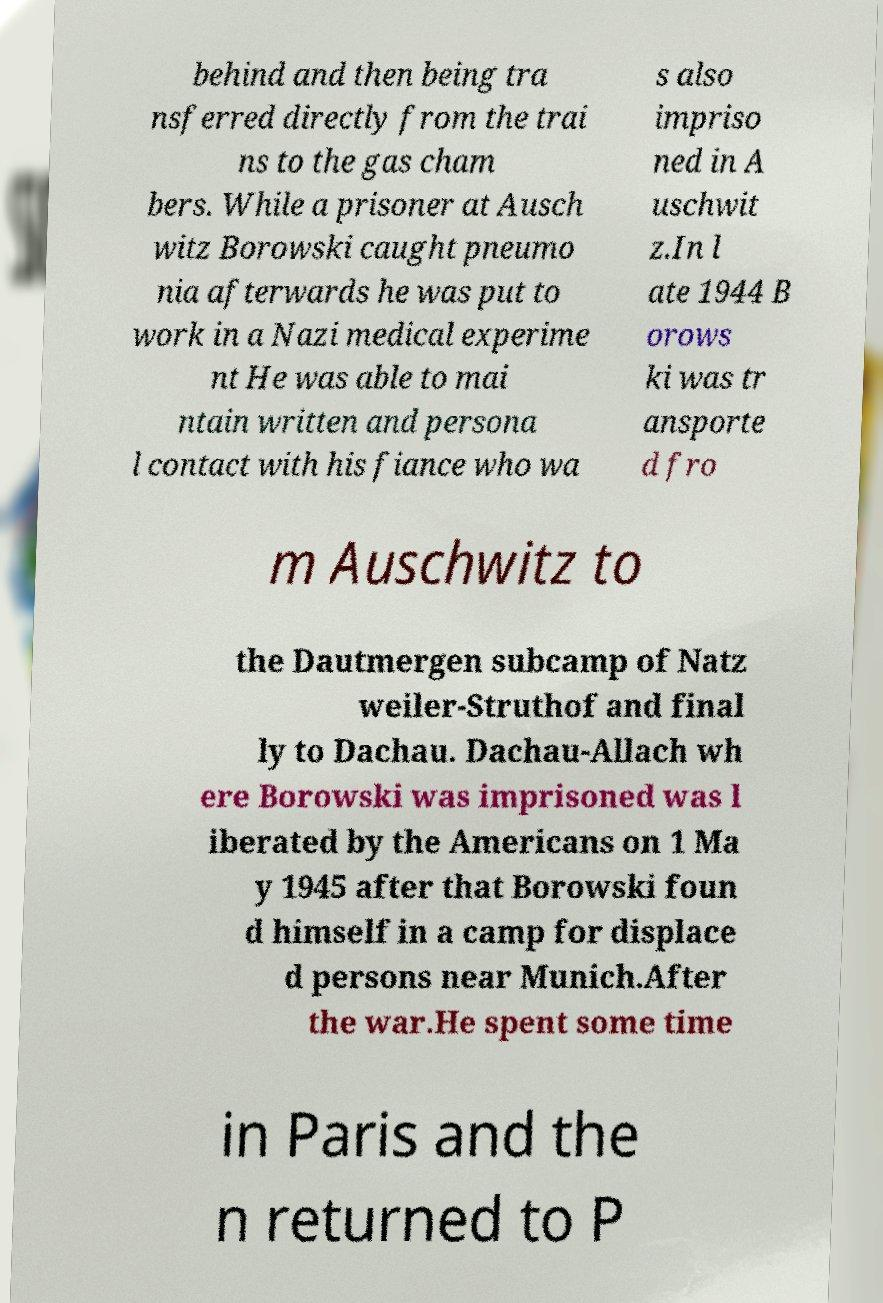Please identify and transcribe the text found in this image. behind and then being tra nsferred directly from the trai ns to the gas cham bers. While a prisoner at Ausch witz Borowski caught pneumo nia afterwards he was put to work in a Nazi medical experime nt He was able to mai ntain written and persona l contact with his fiance who wa s also impriso ned in A uschwit z.In l ate 1944 B orows ki was tr ansporte d fro m Auschwitz to the Dautmergen subcamp of Natz weiler-Struthof and final ly to Dachau. Dachau-Allach wh ere Borowski was imprisoned was l iberated by the Americans on 1 Ma y 1945 after that Borowski foun d himself in a camp for displace d persons near Munich.After the war.He spent some time in Paris and the n returned to P 